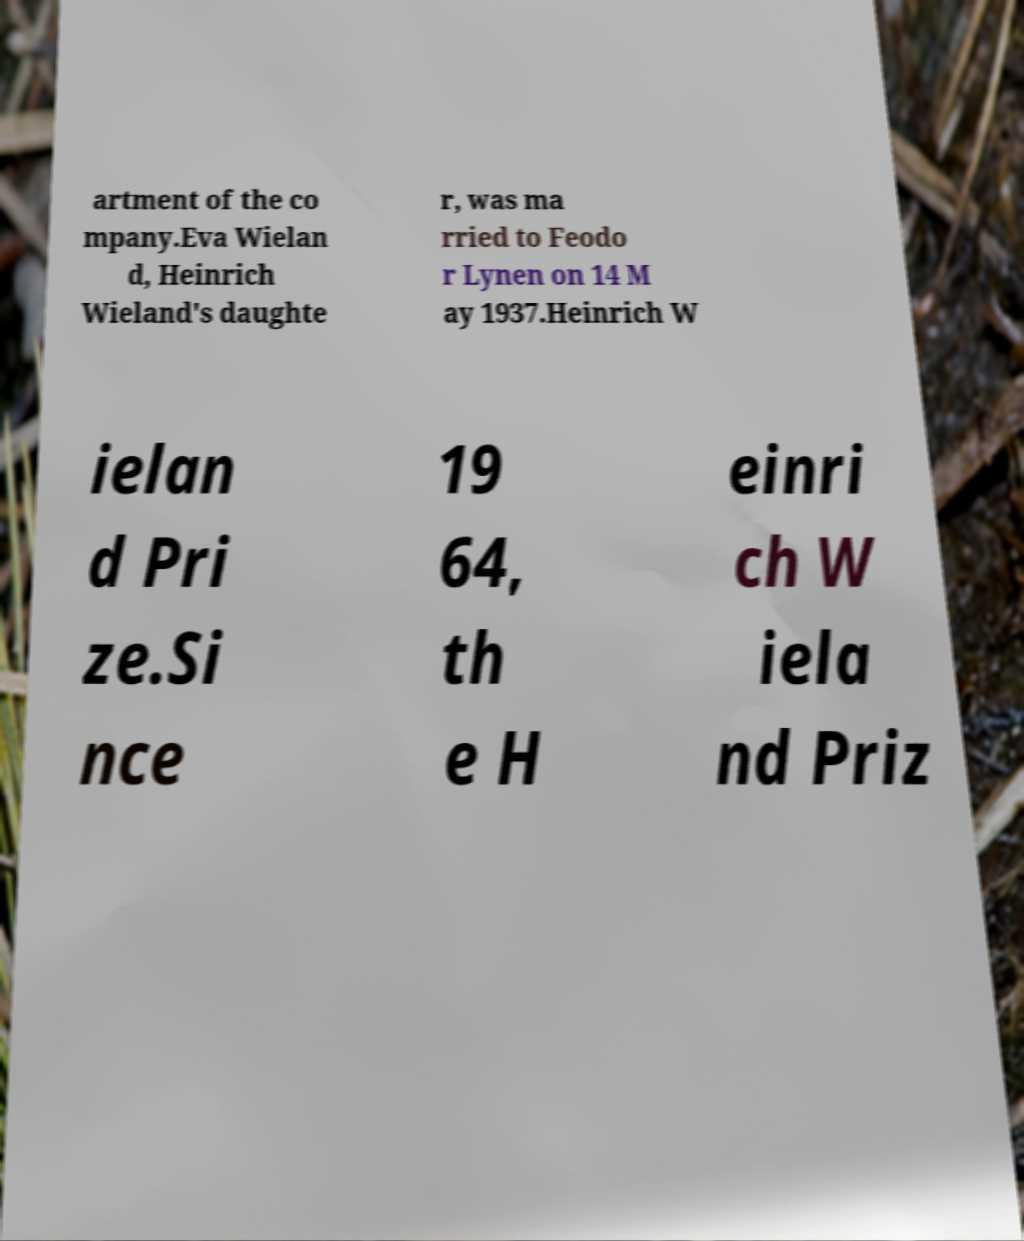For documentation purposes, I need the text within this image transcribed. Could you provide that? artment of the co mpany.Eva Wielan d, Heinrich Wieland's daughte r, was ma rried to Feodo r Lynen on 14 M ay 1937.Heinrich W ielan d Pri ze.Si nce 19 64, th e H einri ch W iela nd Priz 